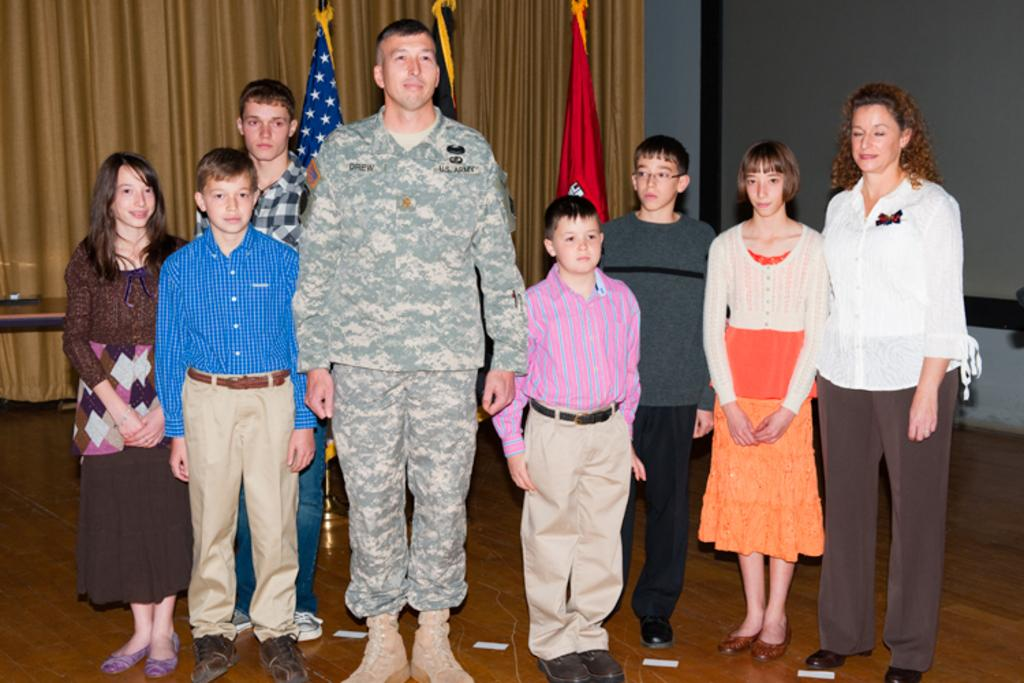How many people are in the image? There are persons standing in the image. What are the people wearing? The persons are wearing clothes. What can be seen in the top left corner of the image? There is a curtain in the top left of the image. What is present at the top of the image? There are flags at the top of the image. What type of sweater is the person wearing in the image? There is no sweater mentioned in the image, and the people are only described as wearing clothes. How long does it take for the person to walk across the image? The image is a still photograph, so there is no movement or time involved in the scene. 